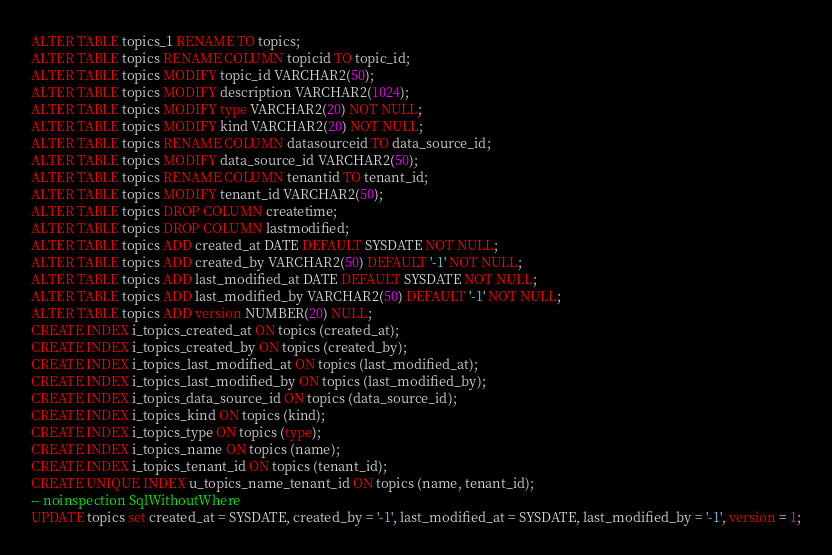<code> <loc_0><loc_0><loc_500><loc_500><_SQL_>ALTER TABLE topics_1 RENAME TO topics;
ALTER TABLE topics RENAME COLUMN topicid TO topic_id;
ALTER TABLE topics MODIFY topic_id VARCHAR2(50);
ALTER TABLE topics MODIFY description VARCHAR2(1024);
ALTER TABLE topics MODIFY type VARCHAR2(20) NOT NULL;
ALTER TABLE topics MODIFY kind VARCHAR2(20) NOT NULL;
ALTER TABLE topics RENAME COLUMN datasourceid TO data_source_id;
ALTER TABLE topics MODIFY data_source_id VARCHAR2(50);
ALTER TABLE topics RENAME COLUMN tenantid TO tenant_id;
ALTER TABLE topics MODIFY tenant_id VARCHAR2(50);
ALTER TABLE topics DROP COLUMN createtime;
ALTER TABLE topics DROP COLUMN lastmodified;
ALTER TABLE topics ADD created_at DATE DEFAULT SYSDATE NOT NULL;
ALTER TABLE topics ADD created_by VARCHAR2(50) DEFAULT '-1' NOT NULL;
ALTER TABLE topics ADD last_modified_at DATE DEFAULT SYSDATE NOT NULL;
ALTER TABLE topics ADD last_modified_by VARCHAR2(50) DEFAULT '-1' NOT NULL;
ALTER TABLE topics ADD version NUMBER(20) NULL;
CREATE INDEX i_topics_created_at ON topics (created_at);
CREATE INDEX i_topics_created_by ON topics (created_by);
CREATE INDEX i_topics_last_modified_at ON topics (last_modified_at);
CREATE INDEX i_topics_last_modified_by ON topics (last_modified_by);
CREATE INDEX i_topics_data_source_id ON topics (data_source_id);
CREATE INDEX i_topics_kind ON topics (kind);
CREATE INDEX i_topics_type ON topics (type);
CREATE INDEX i_topics_name ON topics (name);
CREATE INDEX i_topics_tenant_id ON topics (tenant_id);
CREATE UNIQUE INDEX u_topics_name_tenant_id ON topics (name, tenant_id);
-- noinspection SqlWithoutWhere
UPDATE topics set created_at = SYSDATE, created_by = '-1', last_modified_at = SYSDATE, last_modified_by = '-1', version = 1;
</code> 